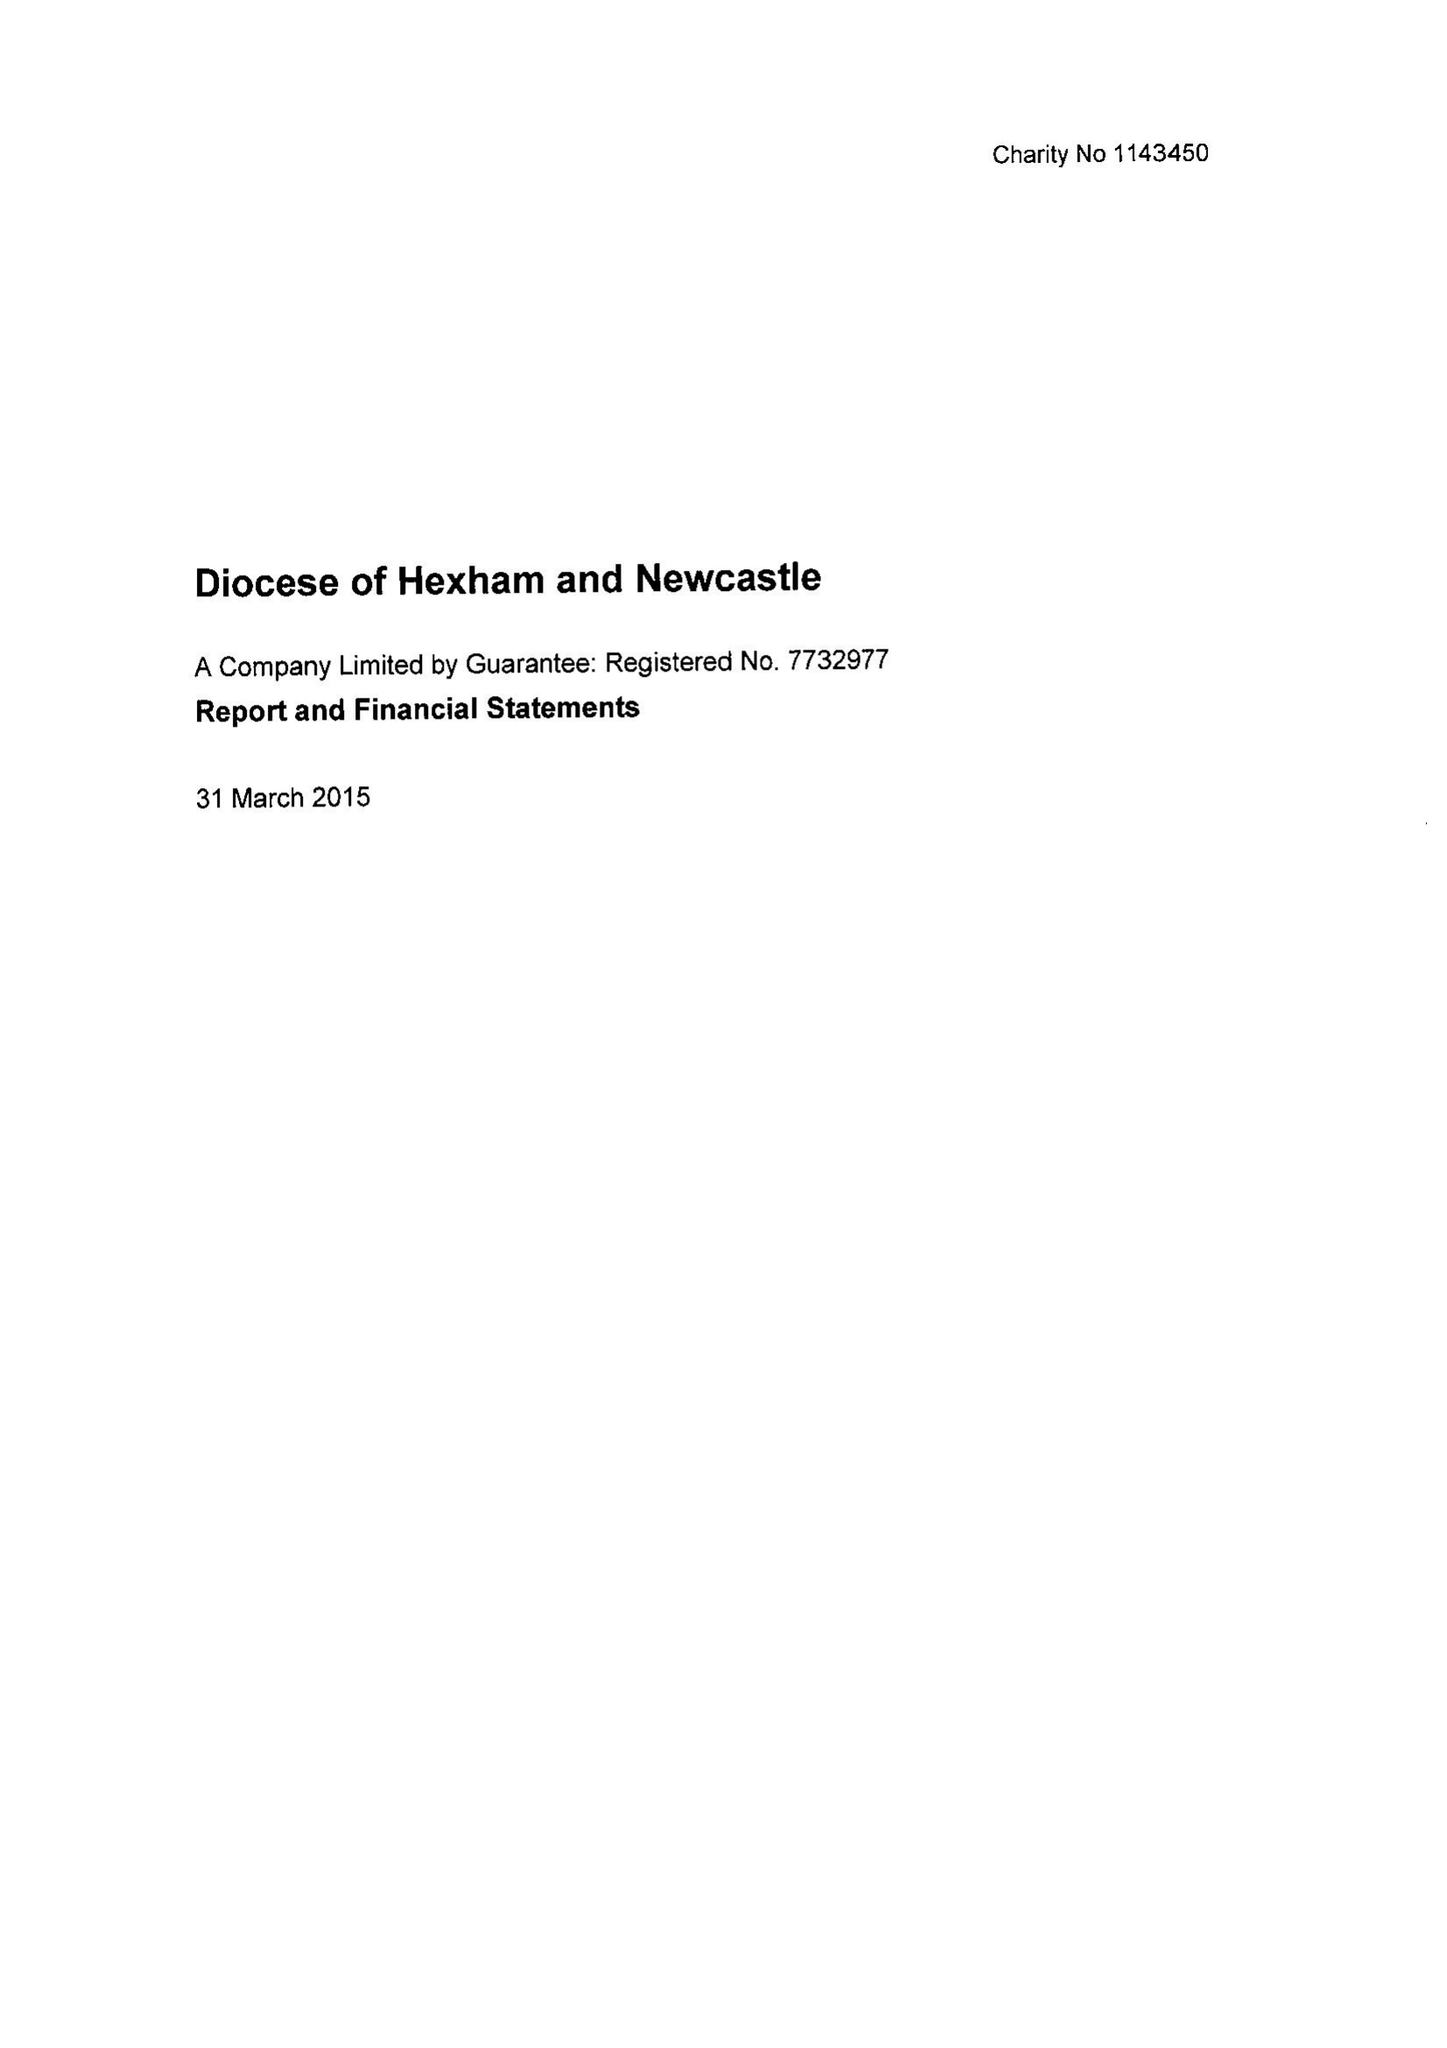What is the value for the charity_number?
Answer the question using a single word or phrase. 1143450 